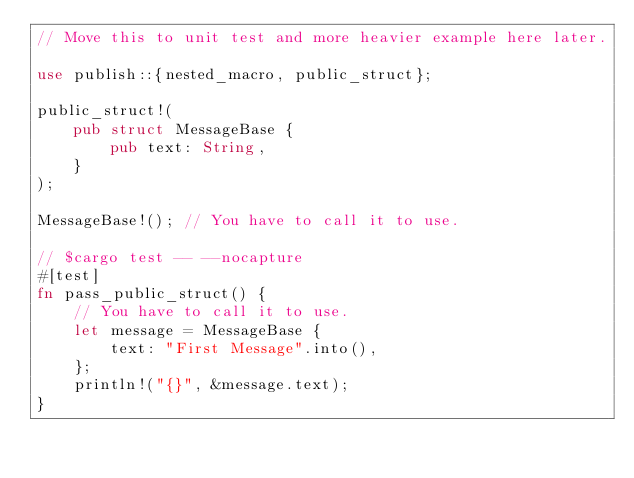<code> <loc_0><loc_0><loc_500><loc_500><_Rust_>// Move this to unit test and more heavier example here later.

use publish::{nested_macro, public_struct};

public_struct!(
    pub struct MessageBase {
        pub text: String,
    }
);

MessageBase!(); // You have to call it to use.

// $cargo test -- --nocapture
#[test]
fn pass_public_struct() {
    // You have to call it to use.
    let message = MessageBase {
        text: "First Message".into(),
    };
    println!("{}", &message.text);
}
</code> 